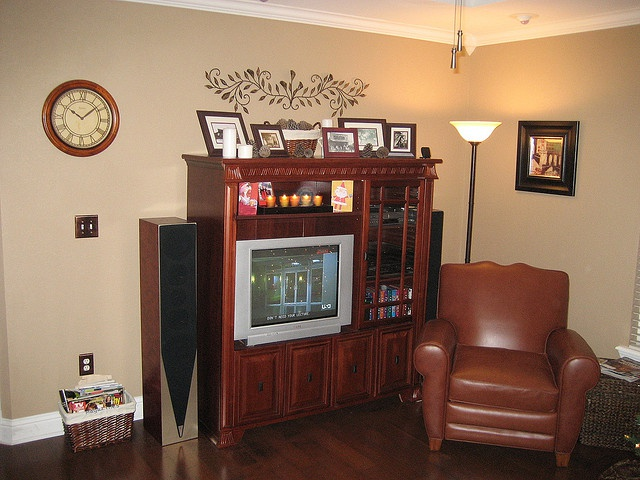Describe the objects in this image and their specific colors. I can see chair in gray, maroon, brown, and black tones, tv in gray, darkgray, and black tones, clock in gray and tan tones, book in gray, black, darkgray, and tan tones, and book in gray, maroon, and darkgray tones in this image. 